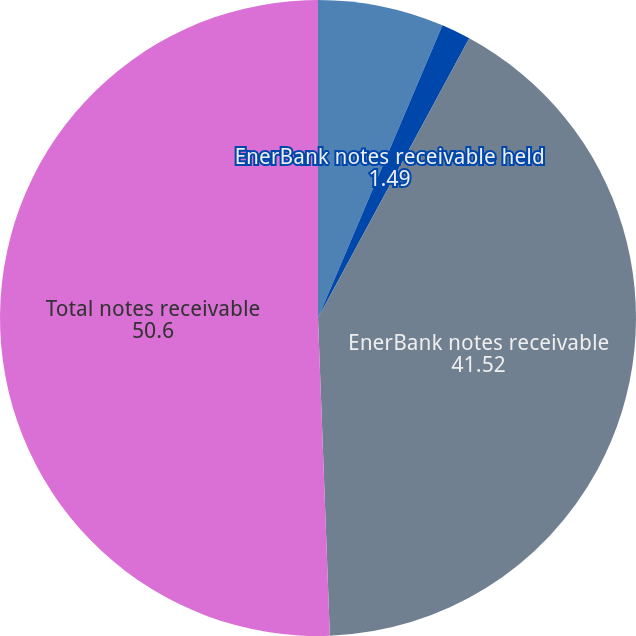Convert chart to OTSL. <chart><loc_0><loc_0><loc_500><loc_500><pie_chart><fcel>EnerBank notes receivable net<fcel>EnerBank notes receivable held<fcel>EnerBank notes receivable<fcel>Total notes receivable<nl><fcel>6.4%<fcel>1.49%<fcel>41.52%<fcel>50.6%<nl></chart> 